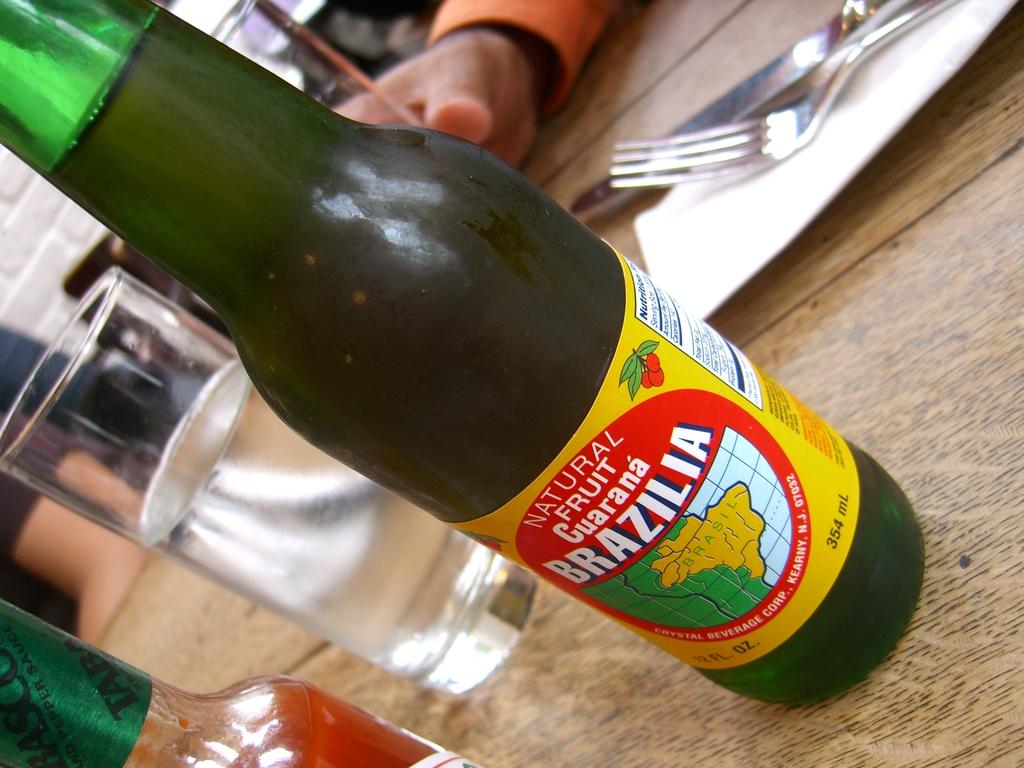Is the fruit artificial or natural in the beverage?
Your response must be concise. Natural. What brand of drink is htis?
Give a very brief answer. Brazilia. 